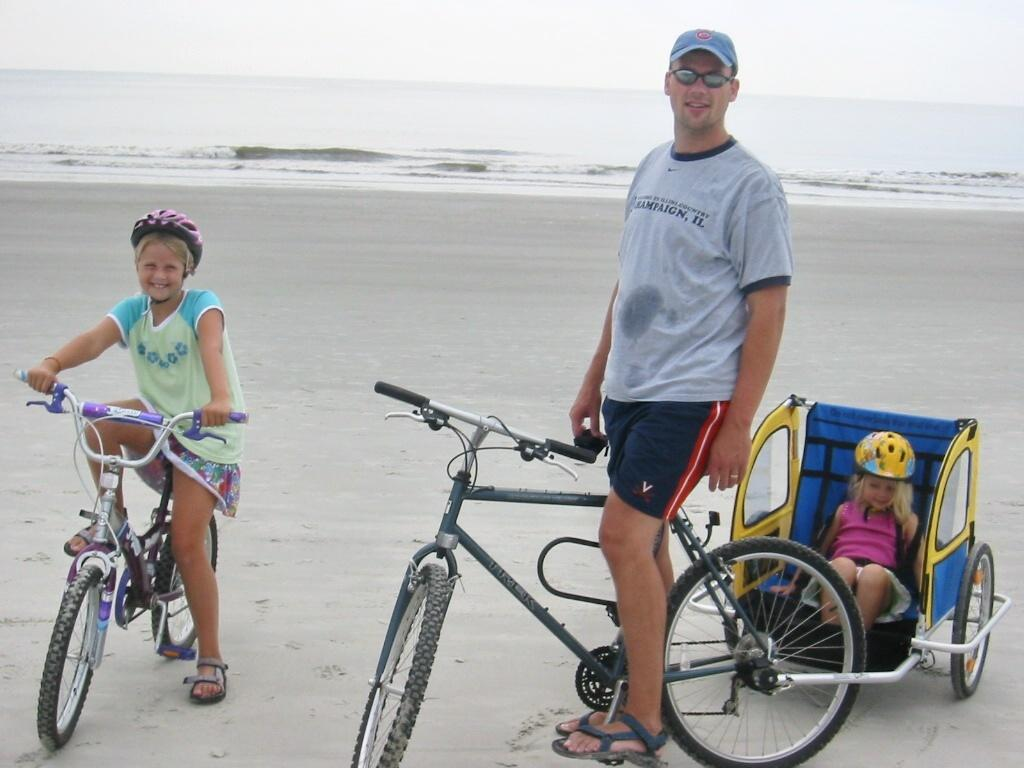How many people are in the picture? There are three members in the picture. What are two of them doing in the picture? Two of them are cycling. What is the third member doing in the picture? One member is in a trolley. What can be seen in the background of the picture? There is an ocean and the sky visible in the background of the picture. What is the tendency of the attention of the cyclists in the picture? There is no information about the cyclists' attention in the picture, so we cannot determine their tendency. 